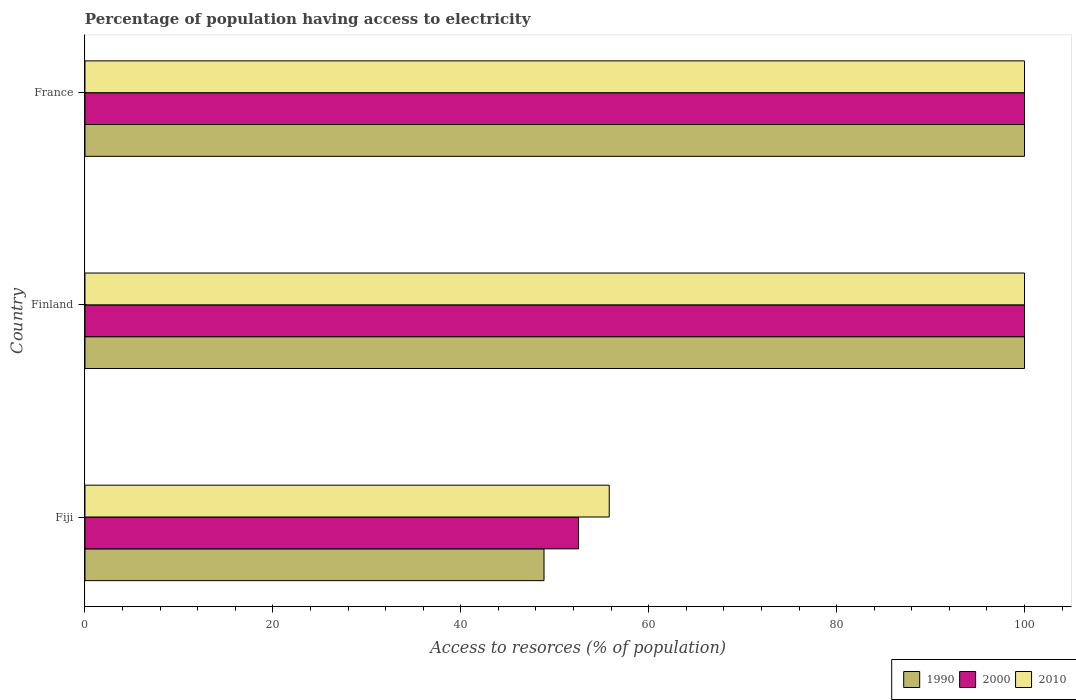How many different coloured bars are there?
Offer a very short reply. 3. How many bars are there on the 1st tick from the top?
Keep it short and to the point. 3. How many bars are there on the 2nd tick from the bottom?
Keep it short and to the point. 3. What is the label of the 3rd group of bars from the top?
Provide a succinct answer. Fiji. Across all countries, what is the minimum percentage of population having access to electricity in 2000?
Your answer should be very brief. 52.53. In which country was the percentage of population having access to electricity in 1990 maximum?
Provide a short and direct response. Finland. In which country was the percentage of population having access to electricity in 2010 minimum?
Your answer should be compact. Fiji. What is the total percentage of population having access to electricity in 2000 in the graph?
Give a very brief answer. 252.53. What is the difference between the percentage of population having access to electricity in 2000 in Fiji and that in France?
Make the answer very short. -47.47. What is the difference between the percentage of population having access to electricity in 1990 in Fiji and the percentage of population having access to electricity in 2010 in Finland?
Your response must be concise. -51.14. What is the average percentage of population having access to electricity in 1990 per country?
Your response must be concise. 82.95. What is the difference between the percentage of population having access to electricity in 2010 and percentage of population having access to electricity in 1990 in Fiji?
Your answer should be compact. 6.94. What is the ratio of the percentage of population having access to electricity in 2010 in Fiji to that in France?
Your answer should be very brief. 0.56. Is the difference between the percentage of population having access to electricity in 2010 in Fiji and France greater than the difference between the percentage of population having access to electricity in 1990 in Fiji and France?
Your response must be concise. Yes. What is the difference between the highest and the lowest percentage of population having access to electricity in 1990?
Keep it short and to the point. 51.14. Is the sum of the percentage of population having access to electricity in 2000 in Finland and France greater than the maximum percentage of population having access to electricity in 2010 across all countries?
Offer a terse response. Yes. What does the 1st bar from the bottom in France represents?
Your answer should be compact. 1990. How many countries are there in the graph?
Ensure brevity in your answer.  3. What is the difference between two consecutive major ticks on the X-axis?
Ensure brevity in your answer.  20. Are the values on the major ticks of X-axis written in scientific E-notation?
Provide a succinct answer. No. Does the graph contain any zero values?
Provide a short and direct response. No. How are the legend labels stacked?
Provide a succinct answer. Horizontal. What is the title of the graph?
Keep it short and to the point. Percentage of population having access to electricity. What is the label or title of the X-axis?
Offer a very short reply. Access to resorces (% of population). What is the Access to resorces (% of population) of 1990 in Fiji?
Offer a very short reply. 48.86. What is the Access to resorces (% of population) of 2000 in Fiji?
Offer a terse response. 52.53. What is the Access to resorces (% of population) in 2010 in Fiji?
Keep it short and to the point. 55.8. What is the Access to resorces (% of population) in 2000 in Finland?
Keep it short and to the point. 100. What is the Access to resorces (% of population) in 1990 in France?
Make the answer very short. 100. What is the Access to resorces (% of population) in 2000 in France?
Your answer should be compact. 100. Across all countries, what is the maximum Access to resorces (% of population) in 1990?
Provide a short and direct response. 100. Across all countries, what is the minimum Access to resorces (% of population) in 1990?
Provide a short and direct response. 48.86. Across all countries, what is the minimum Access to resorces (% of population) of 2000?
Offer a terse response. 52.53. Across all countries, what is the minimum Access to resorces (% of population) of 2010?
Your response must be concise. 55.8. What is the total Access to resorces (% of population) of 1990 in the graph?
Your response must be concise. 248.86. What is the total Access to resorces (% of population) of 2000 in the graph?
Keep it short and to the point. 252.53. What is the total Access to resorces (% of population) in 2010 in the graph?
Provide a short and direct response. 255.8. What is the difference between the Access to resorces (% of population) in 1990 in Fiji and that in Finland?
Provide a succinct answer. -51.14. What is the difference between the Access to resorces (% of population) in 2000 in Fiji and that in Finland?
Your answer should be compact. -47.47. What is the difference between the Access to resorces (% of population) of 2010 in Fiji and that in Finland?
Offer a very short reply. -44.2. What is the difference between the Access to resorces (% of population) in 1990 in Fiji and that in France?
Offer a terse response. -51.14. What is the difference between the Access to resorces (% of population) of 2000 in Fiji and that in France?
Offer a very short reply. -47.47. What is the difference between the Access to resorces (% of population) of 2010 in Fiji and that in France?
Your answer should be very brief. -44.2. What is the difference between the Access to resorces (% of population) of 2000 in Finland and that in France?
Your response must be concise. 0. What is the difference between the Access to resorces (% of population) of 1990 in Fiji and the Access to resorces (% of population) of 2000 in Finland?
Your answer should be very brief. -51.14. What is the difference between the Access to resorces (% of population) in 1990 in Fiji and the Access to resorces (% of population) in 2010 in Finland?
Provide a short and direct response. -51.14. What is the difference between the Access to resorces (% of population) in 2000 in Fiji and the Access to resorces (% of population) in 2010 in Finland?
Your response must be concise. -47.47. What is the difference between the Access to resorces (% of population) in 1990 in Fiji and the Access to resorces (% of population) in 2000 in France?
Your answer should be very brief. -51.14. What is the difference between the Access to resorces (% of population) of 1990 in Fiji and the Access to resorces (% of population) of 2010 in France?
Give a very brief answer. -51.14. What is the difference between the Access to resorces (% of population) in 2000 in Fiji and the Access to resorces (% of population) in 2010 in France?
Offer a terse response. -47.47. What is the average Access to resorces (% of population) in 1990 per country?
Give a very brief answer. 82.95. What is the average Access to resorces (% of population) in 2000 per country?
Your response must be concise. 84.18. What is the average Access to resorces (% of population) in 2010 per country?
Offer a terse response. 85.27. What is the difference between the Access to resorces (% of population) of 1990 and Access to resorces (% of population) of 2000 in Fiji?
Make the answer very short. -3.67. What is the difference between the Access to resorces (% of population) in 1990 and Access to resorces (% of population) in 2010 in Fiji?
Offer a terse response. -6.94. What is the difference between the Access to resorces (% of population) of 2000 and Access to resorces (% of population) of 2010 in Fiji?
Make the answer very short. -3.27. What is the difference between the Access to resorces (% of population) in 1990 and Access to resorces (% of population) in 2000 in Finland?
Give a very brief answer. 0. What is the difference between the Access to resorces (% of population) of 1990 and Access to resorces (% of population) of 2010 in Finland?
Ensure brevity in your answer.  0. What is the difference between the Access to resorces (% of population) in 2000 and Access to resorces (% of population) in 2010 in Finland?
Offer a terse response. 0. What is the difference between the Access to resorces (% of population) of 2000 and Access to resorces (% of population) of 2010 in France?
Provide a succinct answer. 0. What is the ratio of the Access to resorces (% of population) in 1990 in Fiji to that in Finland?
Provide a short and direct response. 0.49. What is the ratio of the Access to resorces (% of population) in 2000 in Fiji to that in Finland?
Provide a short and direct response. 0.53. What is the ratio of the Access to resorces (% of population) in 2010 in Fiji to that in Finland?
Your response must be concise. 0.56. What is the ratio of the Access to resorces (% of population) in 1990 in Fiji to that in France?
Keep it short and to the point. 0.49. What is the ratio of the Access to resorces (% of population) of 2000 in Fiji to that in France?
Make the answer very short. 0.53. What is the ratio of the Access to resorces (% of population) in 2010 in Fiji to that in France?
Provide a short and direct response. 0.56. What is the ratio of the Access to resorces (% of population) of 2010 in Finland to that in France?
Provide a short and direct response. 1. What is the difference between the highest and the second highest Access to resorces (% of population) of 1990?
Your answer should be compact. 0. What is the difference between the highest and the lowest Access to resorces (% of population) of 1990?
Provide a short and direct response. 51.14. What is the difference between the highest and the lowest Access to resorces (% of population) in 2000?
Offer a terse response. 47.47. What is the difference between the highest and the lowest Access to resorces (% of population) in 2010?
Offer a very short reply. 44.2. 